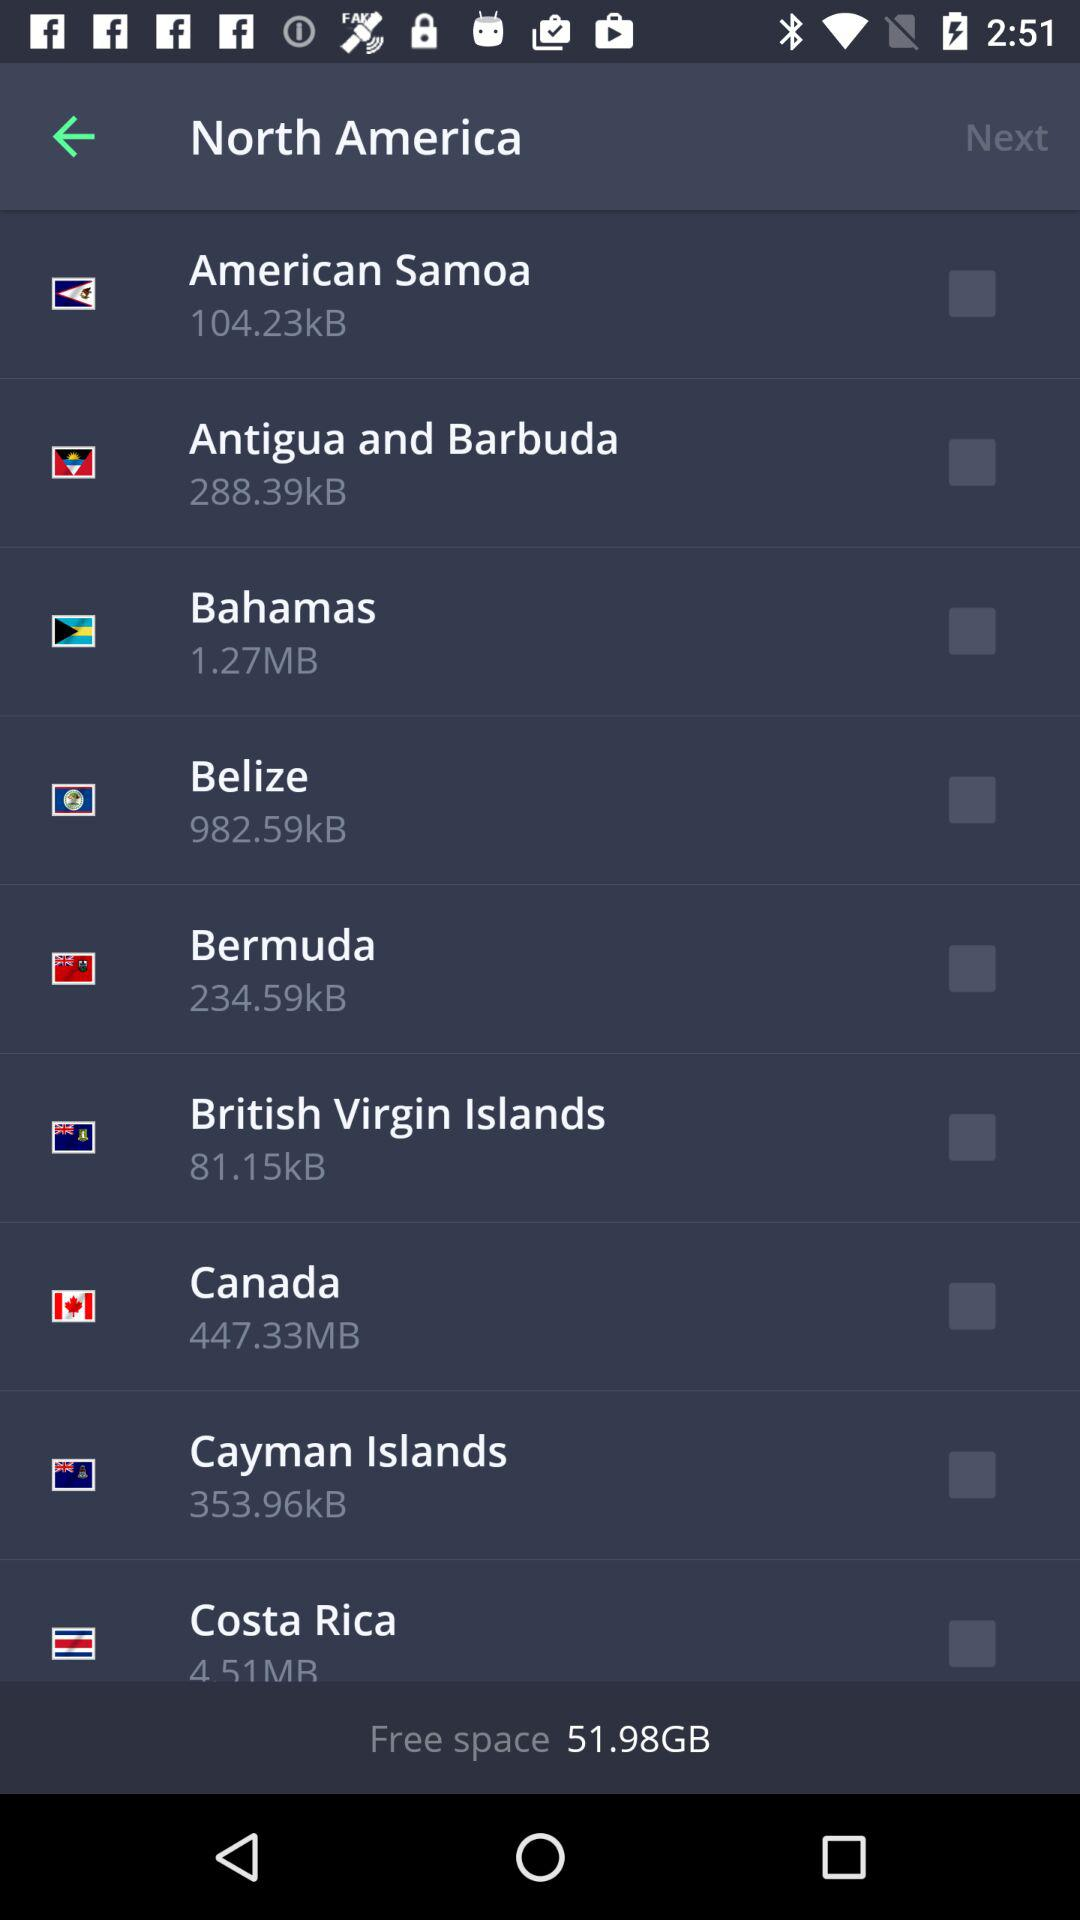What is the status of "Belize"? The status is "off". 